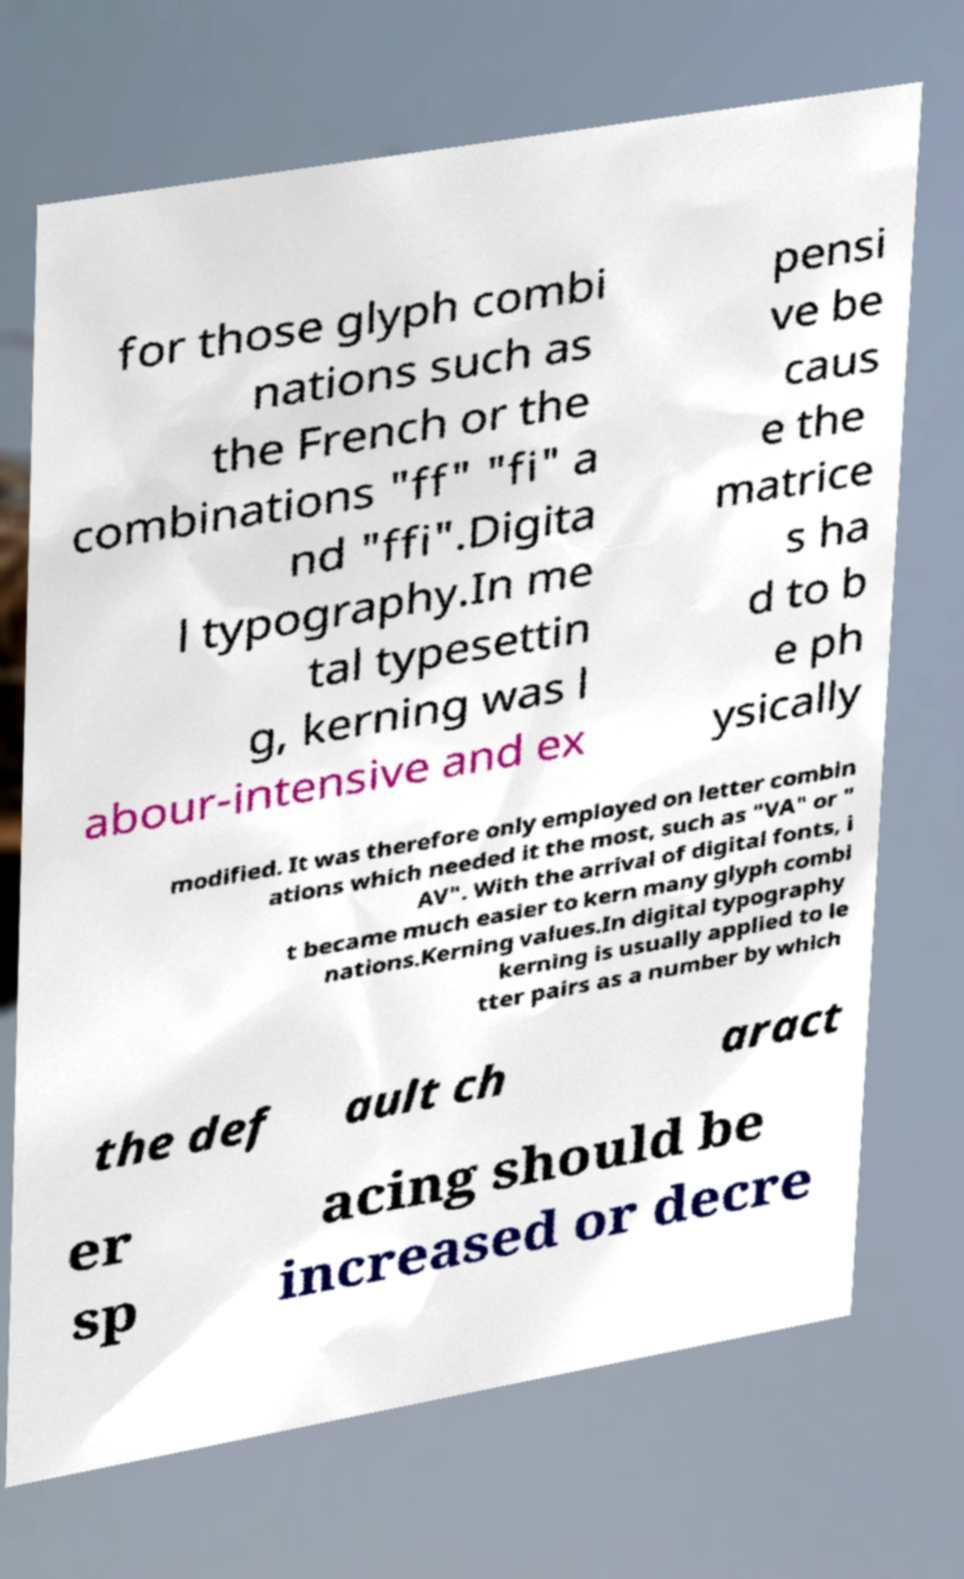Can you accurately transcribe the text from the provided image for me? for those glyph combi nations such as the French or the combinations "ff" "fi" a nd "ffi".Digita l typography.In me tal typesettin g, kerning was l abour-intensive and ex pensi ve be caus e the matrice s ha d to b e ph ysically modified. It was therefore only employed on letter combin ations which needed it the most, such as "VA" or " AV". With the arrival of digital fonts, i t became much easier to kern many glyph combi nations.Kerning values.In digital typography kerning is usually applied to le tter pairs as a number by which the def ault ch aract er sp acing should be increased or decre 